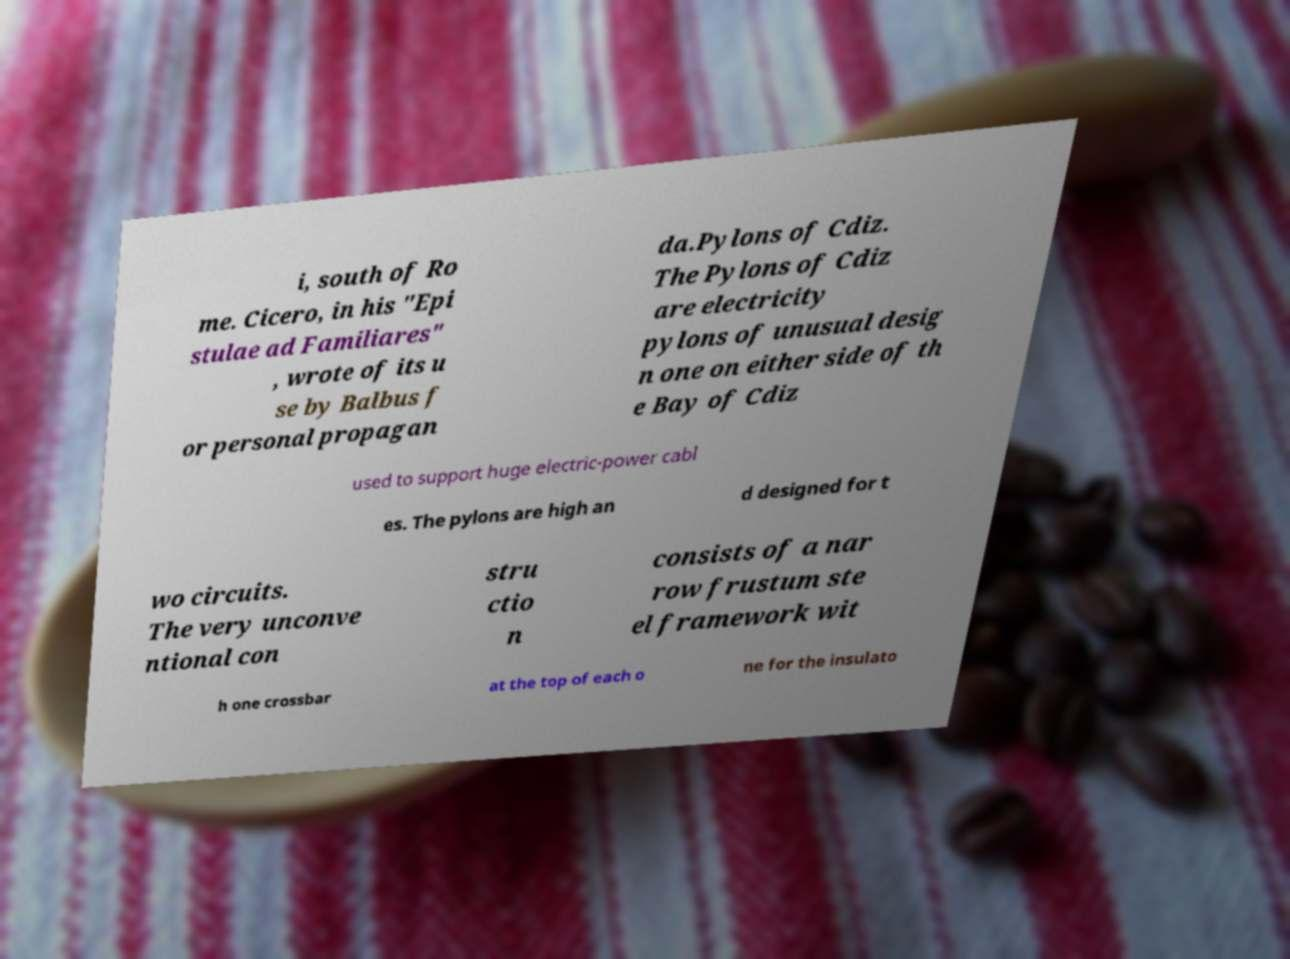Could you extract and type out the text from this image? i, south of Ro me. Cicero, in his "Epi stulae ad Familiares" , wrote of its u se by Balbus f or personal propagan da.Pylons of Cdiz. The Pylons of Cdiz are electricity pylons of unusual desig n one on either side of th e Bay of Cdiz used to support huge electric-power cabl es. The pylons are high an d designed for t wo circuits. The very unconve ntional con stru ctio n consists of a nar row frustum ste el framework wit h one crossbar at the top of each o ne for the insulato 